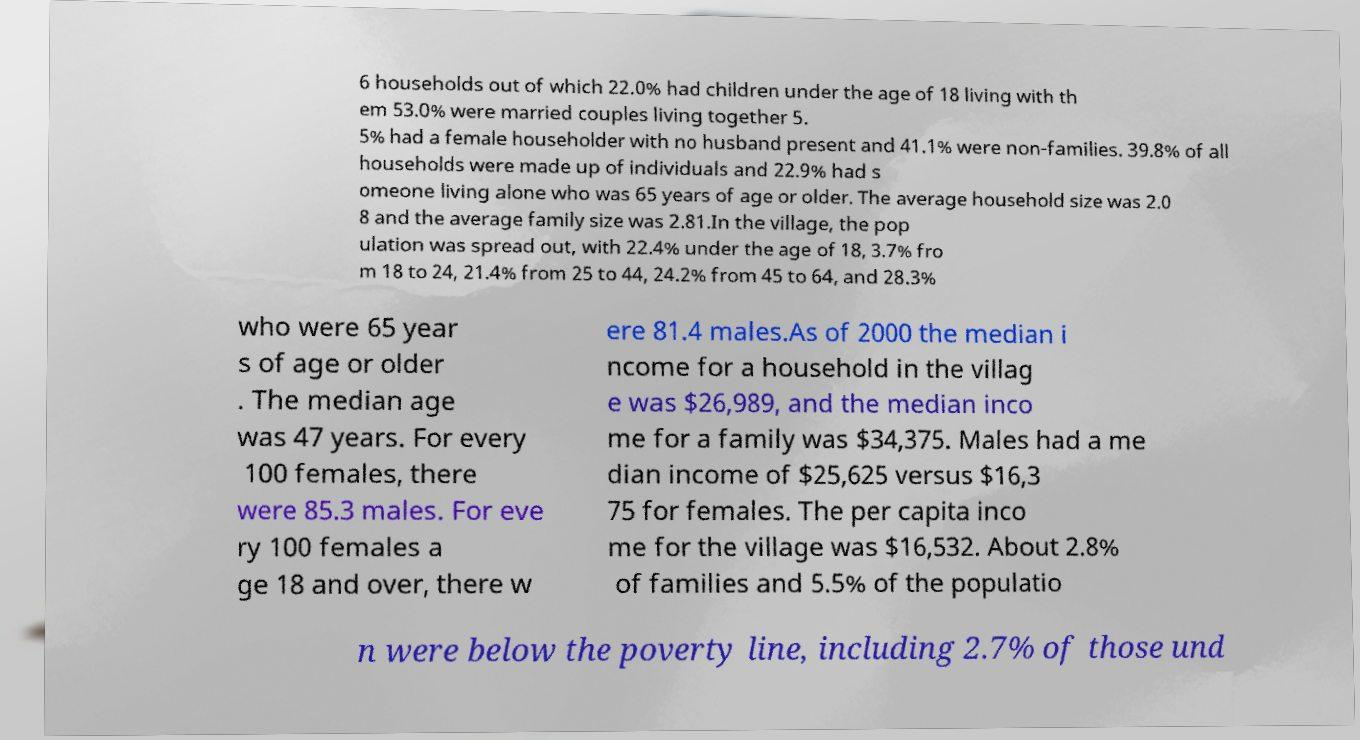Can you read and provide the text displayed in the image?This photo seems to have some interesting text. Can you extract and type it out for me? 6 households out of which 22.0% had children under the age of 18 living with th em 53.0% were married couples living together 5. 5% had a female householder with no husband present and 41.1% were non-families. 39.8% of all households were made up of individuals and 22.9% had s omeone living alone who was 65 years of age or older. The average household size was 2.0 8 and the average family size was 2.81.In the village, the pop ulation was spread out, with 22.4% under the age of 18, 3.7% fro m 18 to 24, 21.4% from 25 to 44, 24.2% from 45 to 64, and 28.3% who were 65 year s of age or older . The median age was 47 years. For every 100 females, there were 85.3 males. For eve ry 100 females a ge 18 and over, there w ere 81.4 males.As of 2000 the median i ncome for a household in the villag e was $26,989, and the median inco me for a family was $34,375. Males had a me dian income of $25,625 versus $16,3 75 for females. The per capita inco me for the village was $16,532. About 2.8% of families and 5.5% of the populatio n were below the poverty line, including 2.7% of those und 